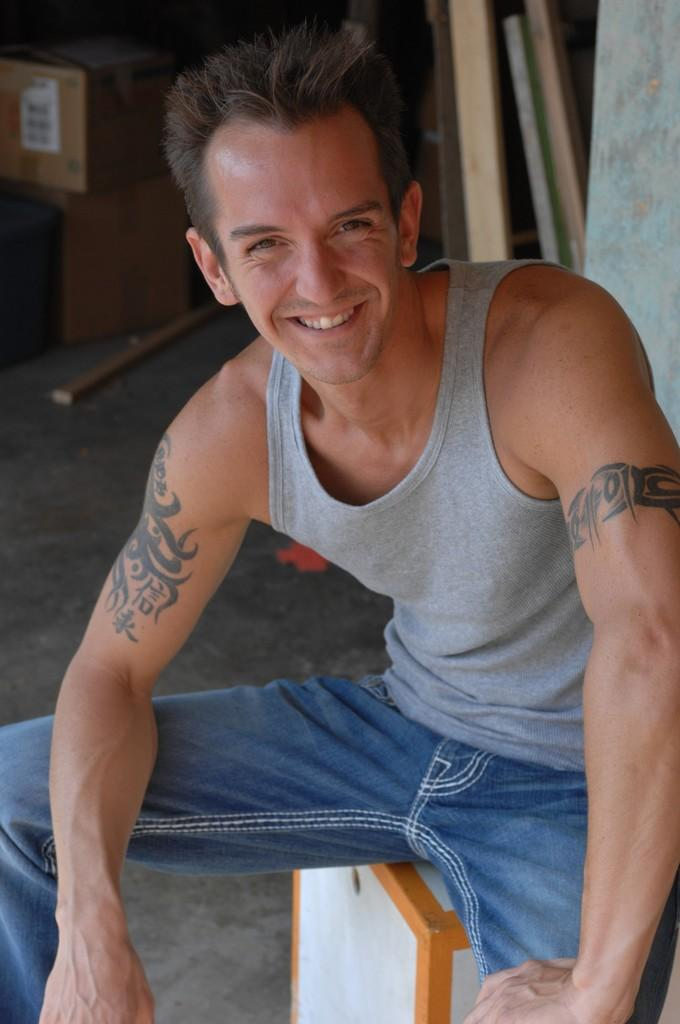What is the man in the image doing? The man is sitting on a stool in the image. What is the man's facial expression? The man is smiling. What can be seen in the background of the image? There is a wall, wood, a box, and other objects in the background of the image. How does the man help the tree grow in the image? There is no tree present in the image, so the man cannot help it grow. 